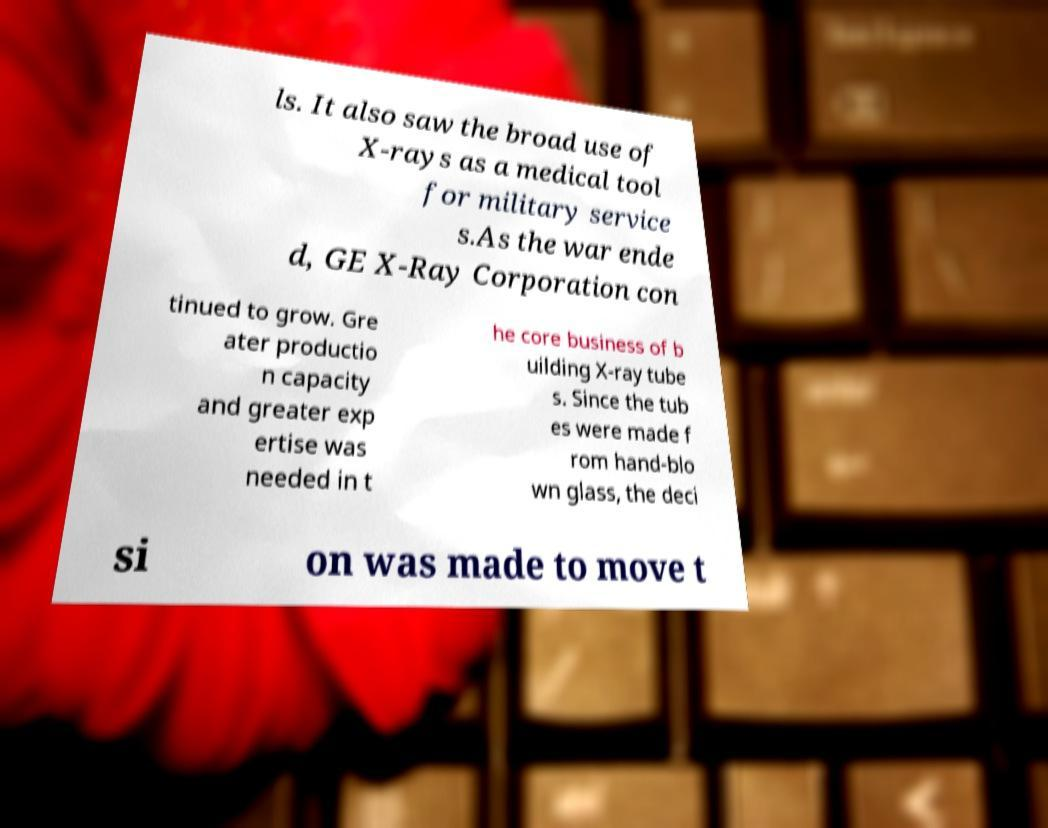Could you extract and type out the text from this image? ls. It also saw the broad use of X-rays as a medical tool for military service s.As the war ende d, GE X-Ray Corporation con tinued to grow. Gre ater productio n capacity and greater exp ertise was needed in t he core business of b uilding X-ray tube s. Since the tub es were made f rom hand-blo wn glass, the deci si on was made to move t 